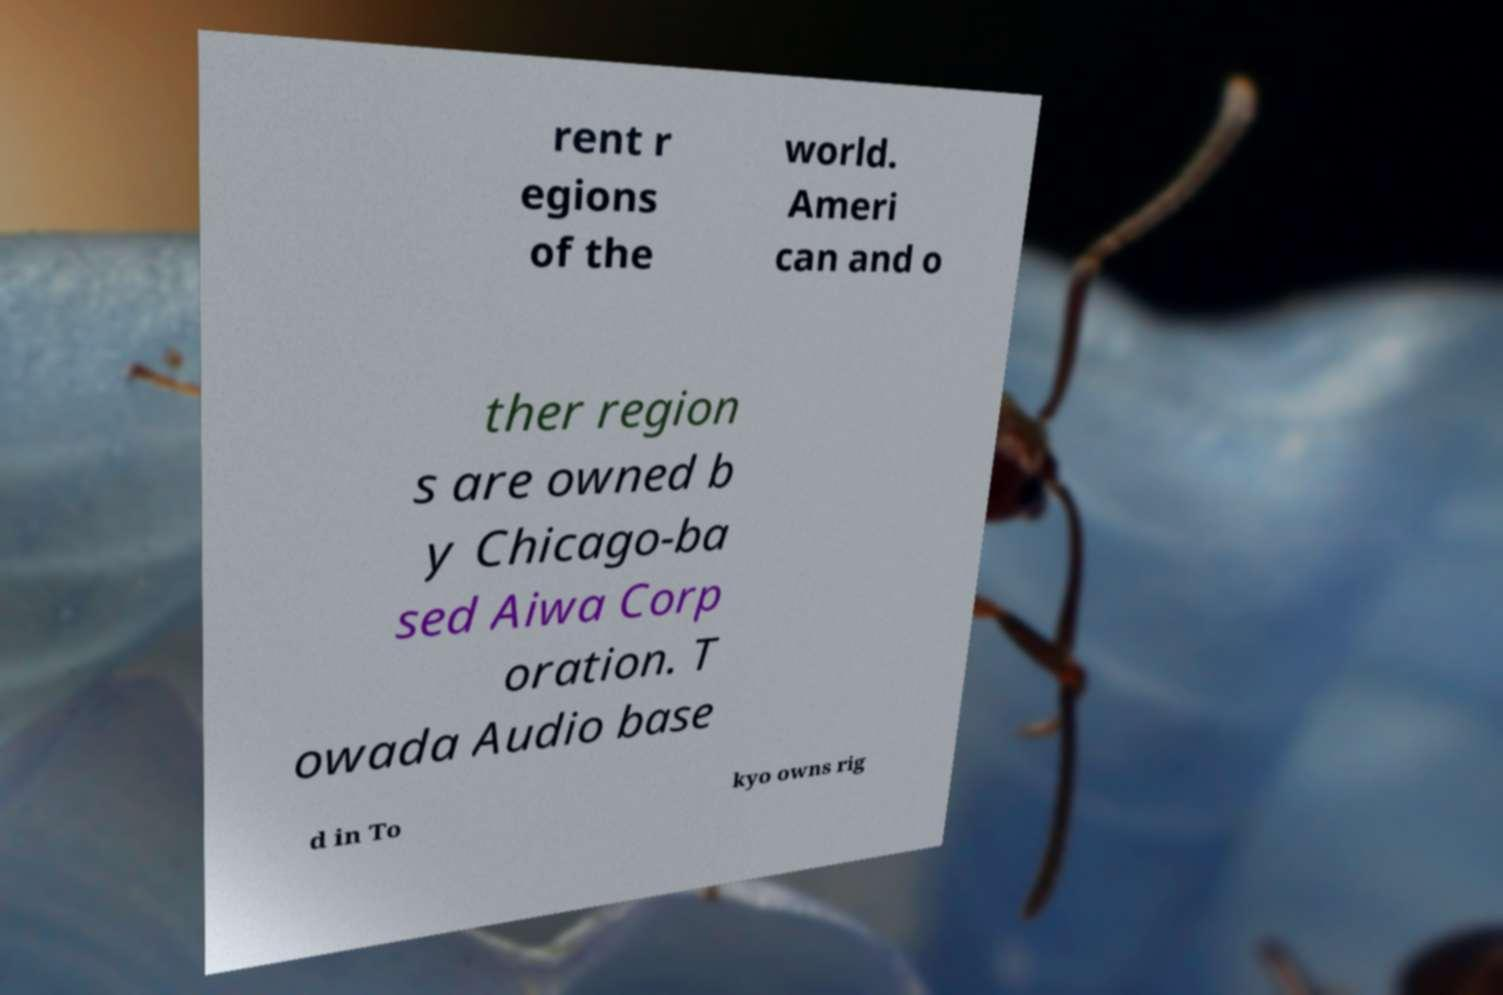I need the written content from this picture converted into text. Can you do that? rent r egions of the world. Ameri can and o ther region s are owned b y Chicago-ba sed Aiwa Corp oration. T owada Audio base d in To kyo owns rig 